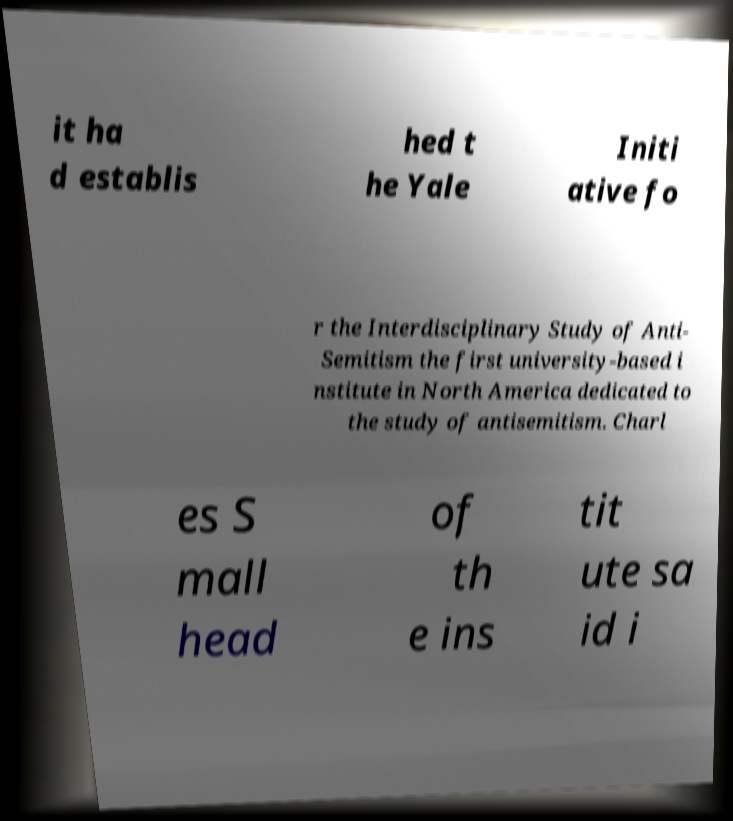Can you read and provide the text displayed in the image?This photo seems to have some interesting text. Can you extract and type it out for me? it ha d establis hed t he Yale Initi ative fo r the Interdisciplinary Study of Anti- Semitism the first university-based i nstitute in North America dedicated to the study of antisemitism. Charl es S mall head of th e ins tit ute sa id i 